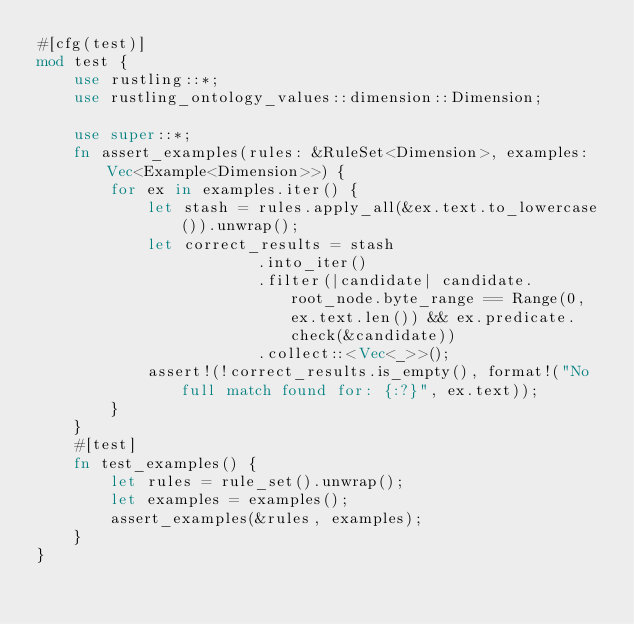<code> <loc_0><loc_0><loc_500><loc_500><_Rust_>#[cfg(test)]
mod test {
    use rustling::*;
    use rustling_ontology_values::dimension::Dimension;
    
    use super::*;
    fn assert_examples(rules: &RuleSet<Dimension>, examples: Vec<Example<Dimension>>) {
        for ex in examples.iter() {
            let stash = rules.apply_all(&ex.text.to_lowercase()).unwrap();
            let correct_results = stash
                        .into_iter()
                        .filter(|candidate| candidate.root_node.byte_range == Range(0, ex.text.len()) && ex.predicate.check(&candidate))
                        .collect::<Vec<_>>();
            assert!(!correct_results.is_empty(), format!("No full match found for: {:?}", ex.text));
        }
    }
    #[test]
    fn test_examples() {
        let rules = rule_set().unwrap();
        let examples = examples();
        assert_examples(&rules, examples);
    }
}
</code> 